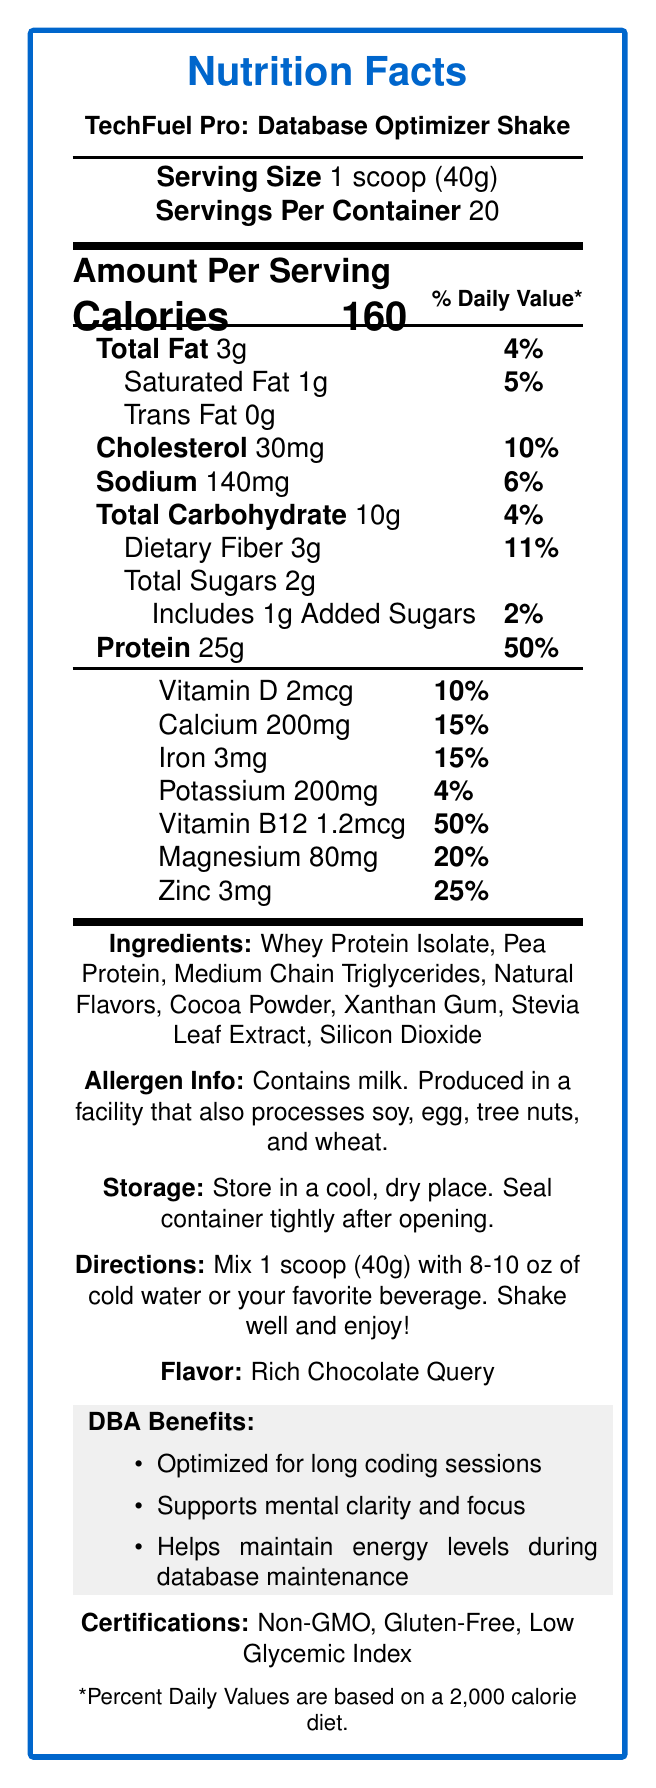what is the serving size? The serving size is clearly stated as "1 scoop (40g)" in the document.
Answer: 1 scoop (40g) how many servings are in one container? The "Servings Per Container" field shows 20.
Answer: 20 how many grams of protein are in each serving? The "Amount Per Serving" section lists Protein as 25g per serving.
Answer: 25g what are the total calories per serving? The "Amount Per Serving" section lists Calories as 160 per serving.
Answer: 160 how many milligrams of calcium are in each serving? The "Vitamin & Minerals" section lists Calcium as 200mg per serving.
Answer: 200mg how much saturated fat is in each serving? The "Amount Per Serving" section lists Saturated Fat as 1g per serving.
Answer: 1g what are the main flavors of the shake? A. Rich Vanilla Mix B. Rich Chocolate Query C. Strawberry Delight D. Banana Bliss The flavor is clearly indicated as "Rich Chocolate Query" in the Flavor section.
Answer: B. Rich Chocolate Query which vitamin has the highest % daily value in a serving? A. Vitamin D B. Calcium C. Vitamin B12 D. Zinc The % Daily Value for Vitamin B12 is 50%, which is the highest among the listed vitamins and minerals.
Answer: C. Vitamin B12 what is the main ingredient in the shake? The ingredient list starts with "Whey Protein Isolate," indicating it is the main ingredient.
Answer: Whey Protein Isolate describe the promotional claims of the product. These claims are stated in the "Marketing claims" section.
Answer: Optimized for long coding sessions, Supports mental clarity and focus, Helps maintain energy levels during database maintenance what certifications does this product hold? The Certifications section highlights these attributes.
Answer: Non-GMO, Gluten-Free, Low Glycemic Index what is the storage recommendation for this product? This instruction is provided in the Storage section.
Answer: Store in a cool, dry place. Seal container tightly after opening. what type of artificial sweetener is used in this product? The Ingredients section lists Stevia Leaf Extract as the sweetener used.
Answer: Stevia Leaf Extract can I determine if the product is safe for someone with a nut allergy just from the document? Although the product itself does not list nuts as an ingredient, it is produced in a facility that processes tree nuts. Therefore, it cannot be determined to be safe for someone with a nut allergy solely from the document.
Answer: Cannot be determined 